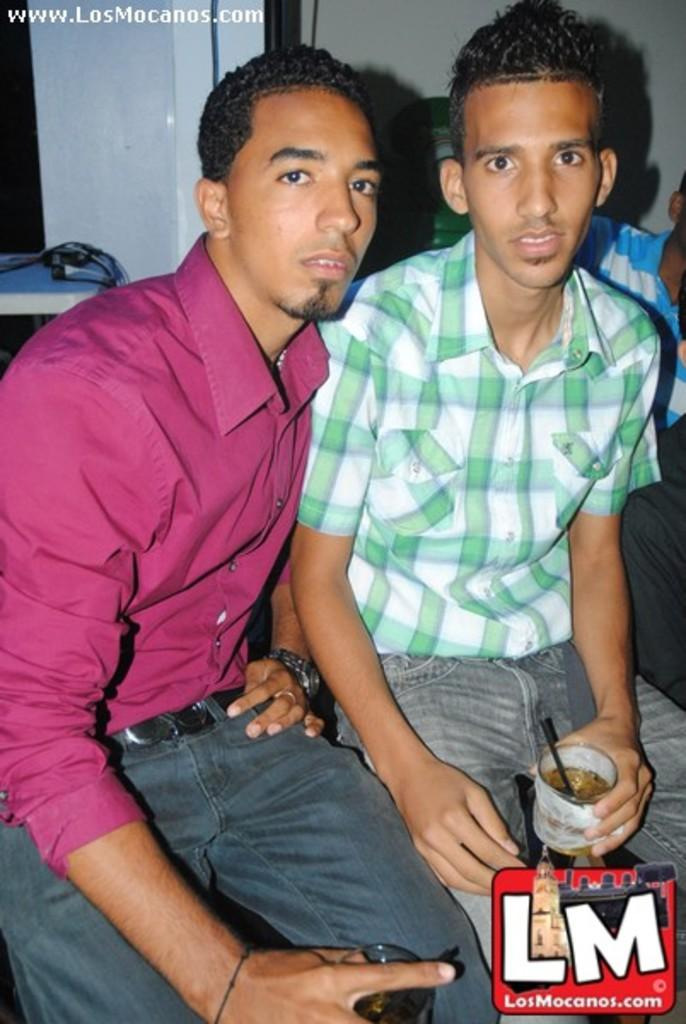How many people are in the image? There are two boys in the image. What are the boys doing in the image? The boys are sitting and holding a cup in their hands. What might be the purpose of the boys holding a cup? The boys might be holding a cup for a photoshoot or to pose for the camera. What can be seen at the bottom front side of the image? There is a watermark quote in the front bottom side of the image. How many pigs are in the image? There are no pigs present in the image. 